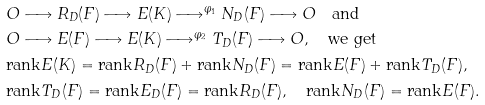Convert formula to latex. <formula><loc_0><loc_0><loc_500><loc_500>& O \longrightarrow R _ { D } ( F ) \longrightarrow E ( K ) \longrightarrow ^ { \varphi _ { 1 } } N _ { D } ( F ) \longrightarrow O \quad \text {and} \\ & O \longrightarrow E ( F ) \longrightarrow E ( K ) \longrightarrow ^ { \varphi _ { 2 } } T _ { D } ( F ) \longrightarrow O , \quad \text {we get} \\ & \text {rank} E ( K ) = \text {rank} R _ { D } ( F ) + \text {rank} N _ { D } ( F ) = \text {rank} E ( F ) + \text {rank} T _ { D } ( F ) , \\ & \text {rank} T _ { D } ( F ) = \text {rank} E _ { D } ( F ) = \text {rank} R _ { D } ( F ) , \quad \text {rank} N _ { D } ( F ) = \text {rank} E ( F ) .</formula> 